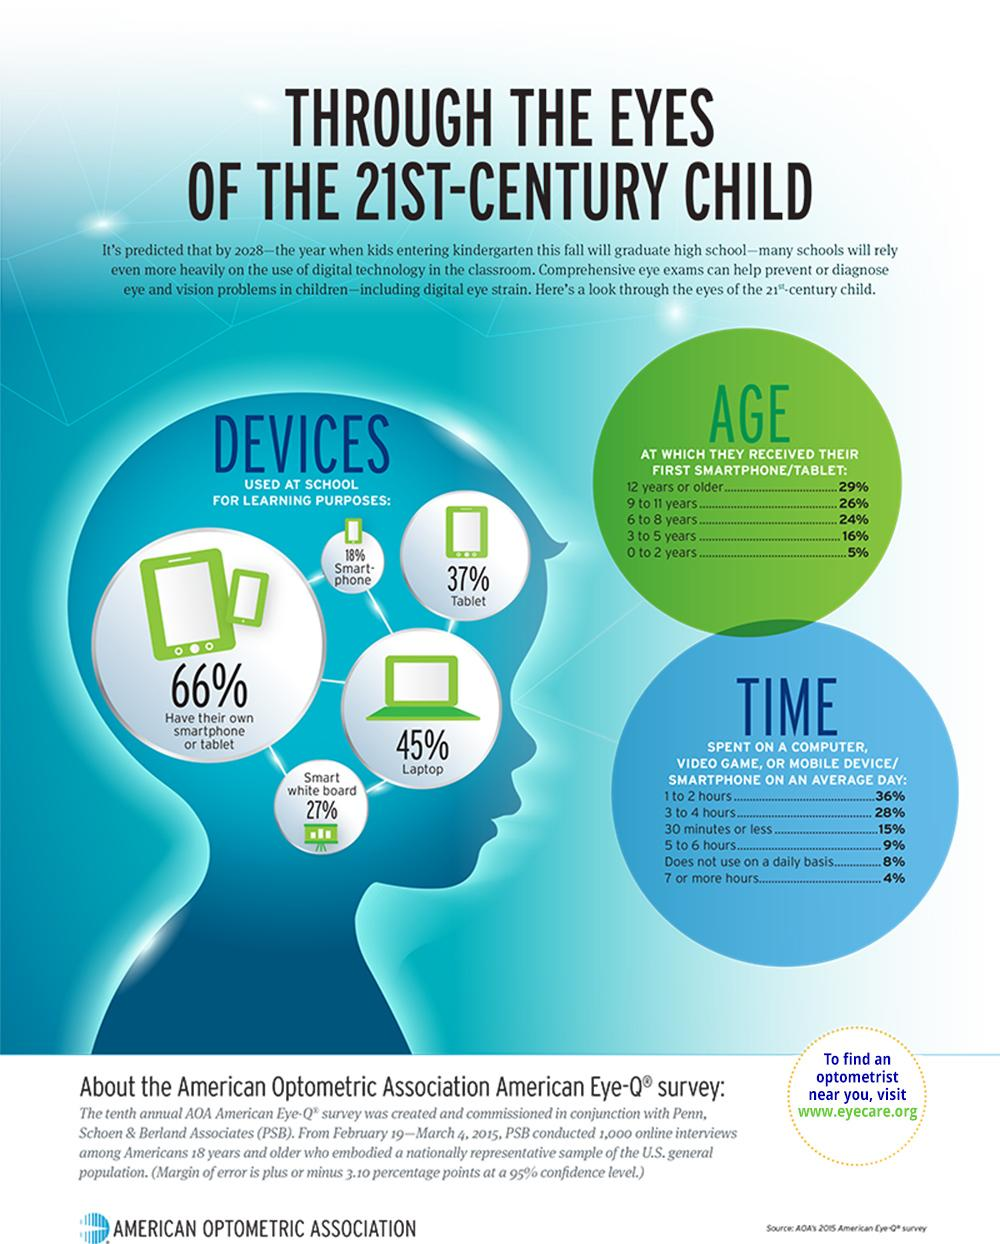Give some essential details in this illustration. The number of children with laptops is greater than the number of children with tablets. There are five age groups listed under the heading "age" in the table. According to a recent study, 79% of children spend 4 hours or less per day on digital devices. According to the given data, approximately 45% of children under the age of 9 received their first smartphone or tablet. The number of children with smart phones is lower than the number of children with laptops or tablets. 